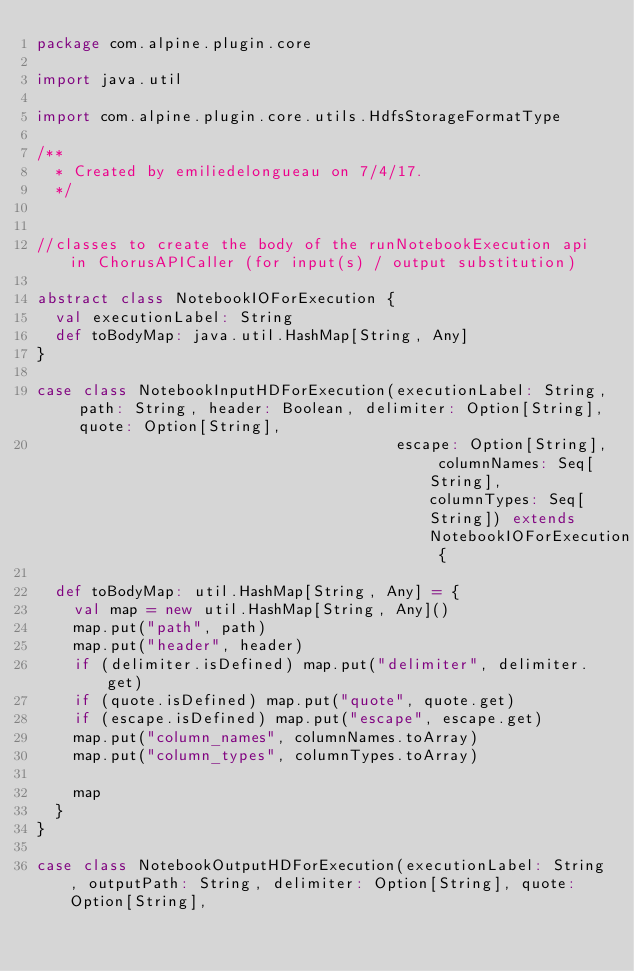<code> <loc_0><loc_0><loc_500><loc_500><_Scala_>package com.alpine.plugin.core

import java.util

import com.alpine.plugin.core.utils.HdfsStorageFormatType

/**
  * Created by emiliedelongueau on 7/4/17.
  */


//classes to create the body of the runNotebookExecution api in ChorusAPICaller (for input(s) / output substitution)

abstract class NotebookIOForExecution {
  val executionLabel: String
  def toBodyMap: java.util.HashMap[String, Any]
}

case class NotebookInputHDForExecution(executionLabel: String, path: String, header: Boolean, delimiter: Option[String], quote: Option[String],
                                       escape: Option[String], columnNames: Seq[String], columnTypes: Seq[String]) extends NotebookIOForExecution {

  def toBodyMap: util.HashMap[String, Any] = {
    val map = new util.HashMap[String, Any]()
    map.put("path", path)
    map.put("header", header)
    if (delimiter.isDefined) map.put("delimiter", delimiter.get)
    if (quote.isDefined) map.put("quote", quote.get)
    if (escape.isDefined) map.put("escape", escape.get)
    map.put("column_names", columnNames.toArray)
    map.put("column_types", columnTypes.toArray)

    map
  }
}

case class NotebookOutputHDForExecution(executionLabel: String, outputPath: String, delimiter: Option[String], quote: Option[String],</code> 